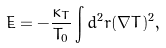<formula> <loc_0><loc_0><loc_500><loc_500>\dot { E } = - \frac { \kappa _ { T } } { T _ { 0 } } \int d ^ { 2 } { r } ( \nabla T ) ^ { 2 } ,</formula> 